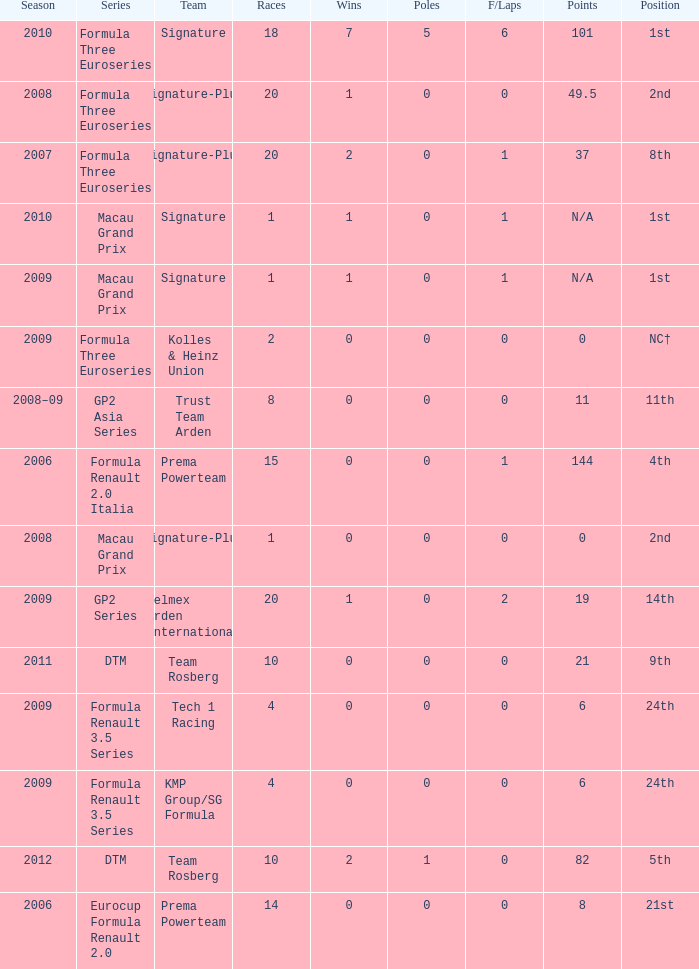How many races did the Formula Three Euroseries signature team have? 18.0. 